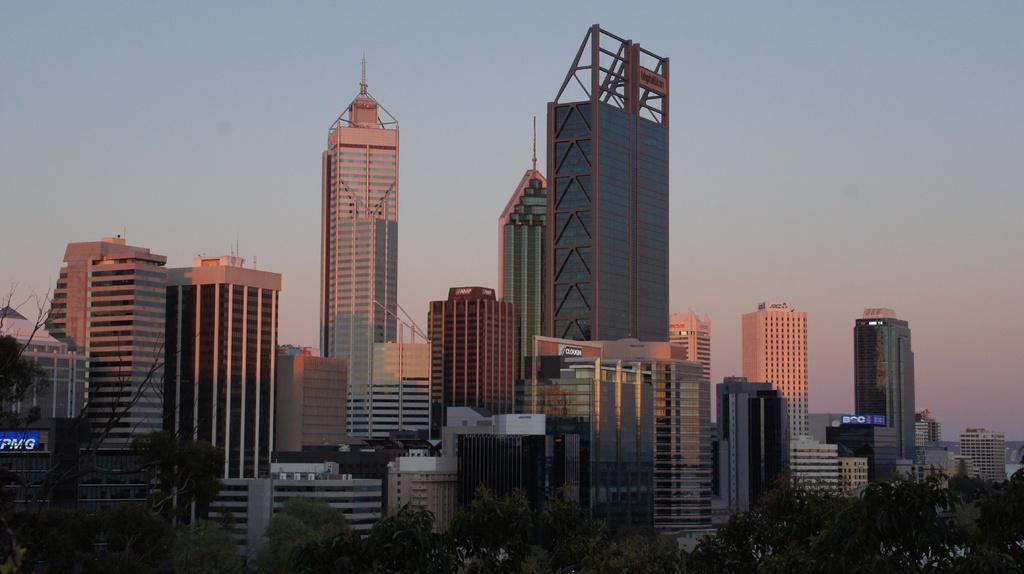What type of natural elements can be seen in the image? There are trees in the image. What man-made structures are visible in the image? There are buildings in the image. What type of signage or advertisements can be seen in the image? There are posters in the image. What can be seen in the background of the image? The sky is visible in the background of the image. What type of nut is being used as a decoration on the jeans in the image? There are no jeans or nuts present in the image. What type of attraction is visible in the image? There is no attraction visible in the image; it features trees, buildings, posters, and the sky. 